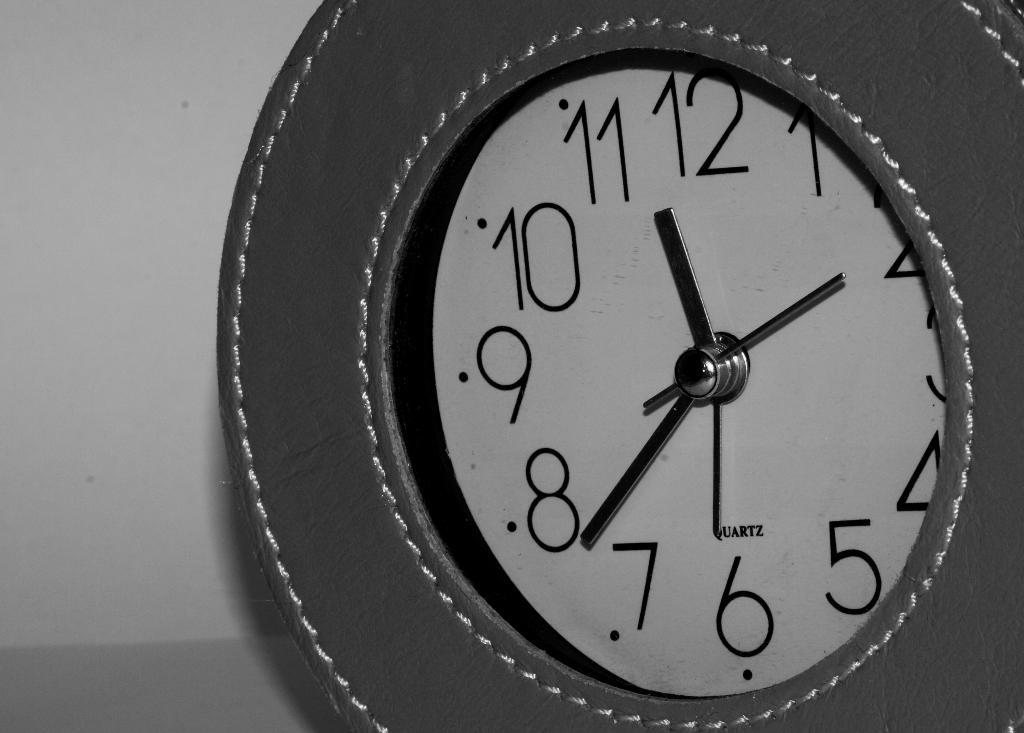<image>
Share a concise interpretation of the image provided. An analogue clock made by quartz sits in front of a wall. 